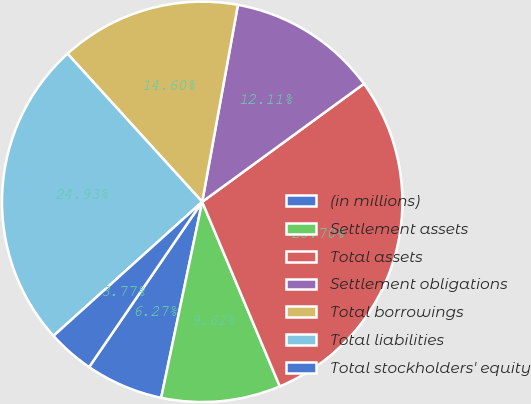Convert chart to OTSL. <chart><loc_0><loc_0><loc_500><loc_500><pie_chart><fcel>(in millions)<fcel>Settlement assets<fcel>Total assets<fcel>Settlement obligations<fcel>Total borrowings<fcel>Total liabilities<fcel>Total stockholders' equity<nl><fcel>6.27%<fcel>9.62%<fcel>28.7%<fcel>12.11%<fcel>14.6%<fcel>24.93%<fcel>3.77%<nl></chart> 